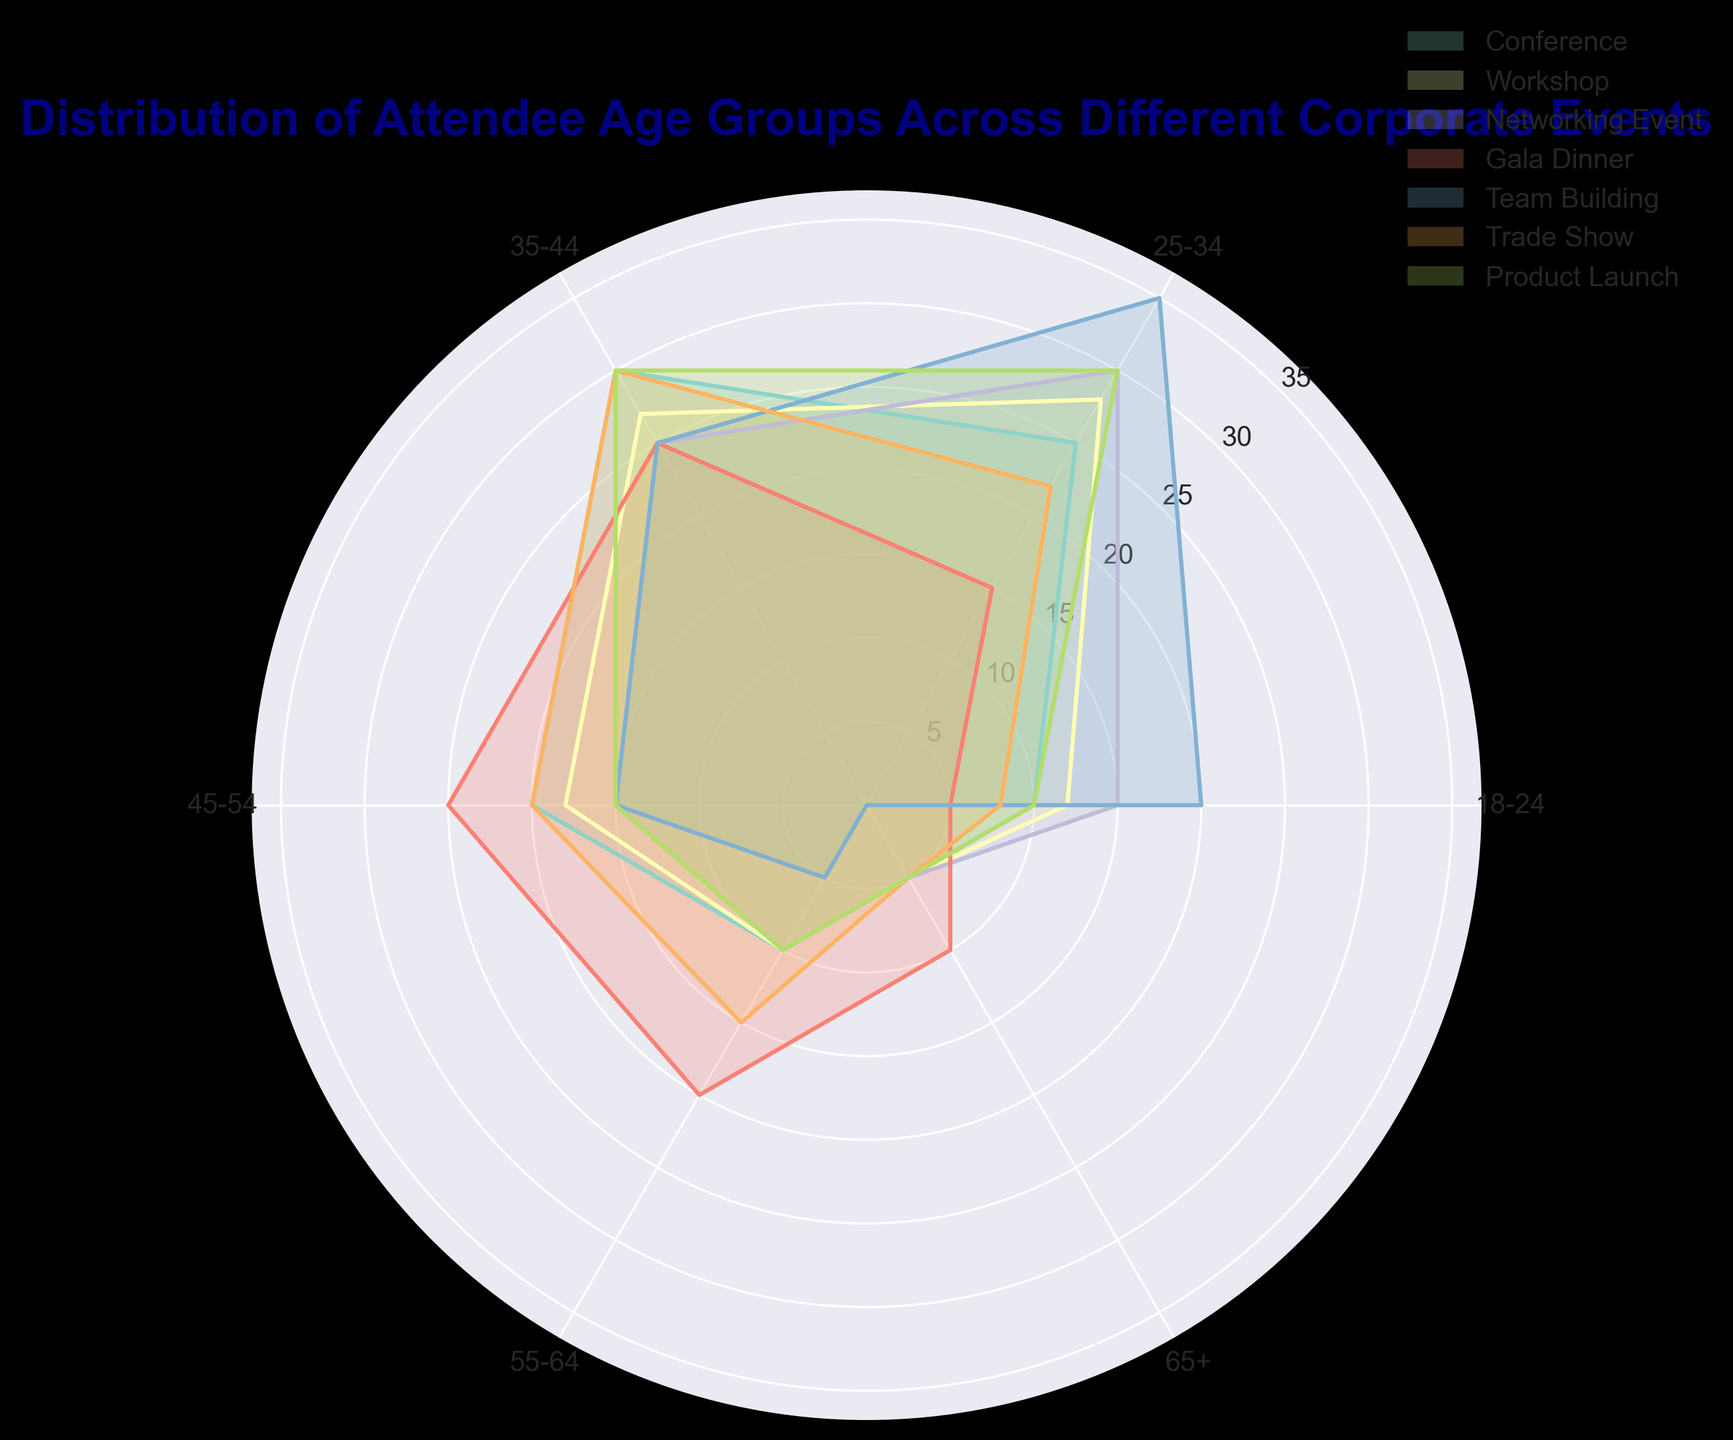Which event has the highest percentage of attendees in the 25-34 age group? Look for the highest bar corresponding to the 25-34 age group across all events. Team Building has the highest percentage at 35%.
Answer: Team Building Which age group has the smallest percentage of attendees across all events? Identify the smallest bar for each event and compare them. The 65+ age group for Team Building has 0%.
Answer: 65+ What is the combined percentage of attendees aged 55-64 across the Conference and Workshop events? Add the percentages: Conference (10%) + Workshop (10%) = 20%
Answer: 20% Between Networking Events and Gala Dinners, which one has a higher percentage of attendees aged 35-44? Compare the bars for the 35-44 age group between the two events. Networking Events have 25% and Gala Dinners have 25%, they are equal.
Answer: They are equal Which event has the greatest variation in percentage distribution across age groups? Identify the event with the largest difference between its highest and lowest percentage values. Team Building has the greatest variation with 35% (25-34 age group) and 0% (65+ age group).
Answer: Team Building In terms of percentage, how does the attendance of the 18-24 age group in Workshops compare to Product Launches? Compare the respective bars' heights for the 18-24 age group. Workshops have 12% while Product Launches have 10%.
Answer: Workshops have a higher percentage Which event has the lowest percentage of attendees aged 45-54? Find the lowest bar for the 45-54 age group across all events. Team Building and Networking Events both have 15%.
Answer: Team Building and Networking Events (tie) What is the average percentage of the 18-24 age group across all events? Sum the percentages for the 18-24 age group across all events and divide by the number of events: (10+12+15+5+20+8+10)/7 = 11.43%
Answer: 11.43% Between Conferences and Trade Shows, which has a higher percentage of attendees aged 55-64? Compare the bar heights for the 55-64 age group between the two events. Conferences and Trade Shows both have 15%.
Answer: They are equal What is the percentage difference between the highest and lowest attendee age groups in Gala Dinner events? Find the difference between the highest (35-44 and 45-54 age groups at 25%) and lowest percentages (18-24 age group at 5%): 25% - 5% = 20%.
Answer: 20% 